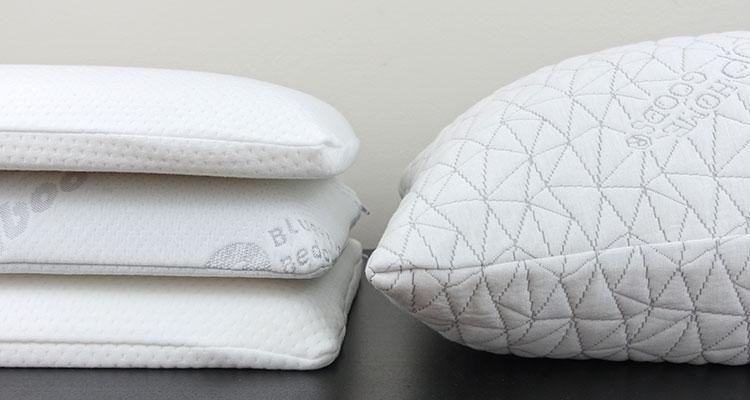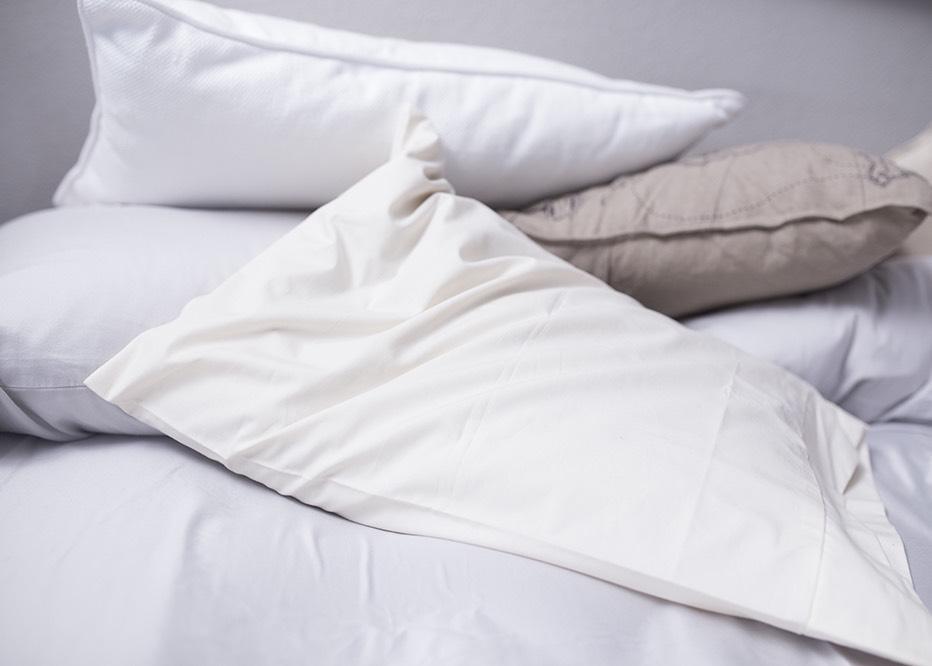The first image is the image on the left, the second image is the image on the right. Analyze the images presented: Is the assertion "There is something pink on a bed." valid? Answer yes or no. No. 